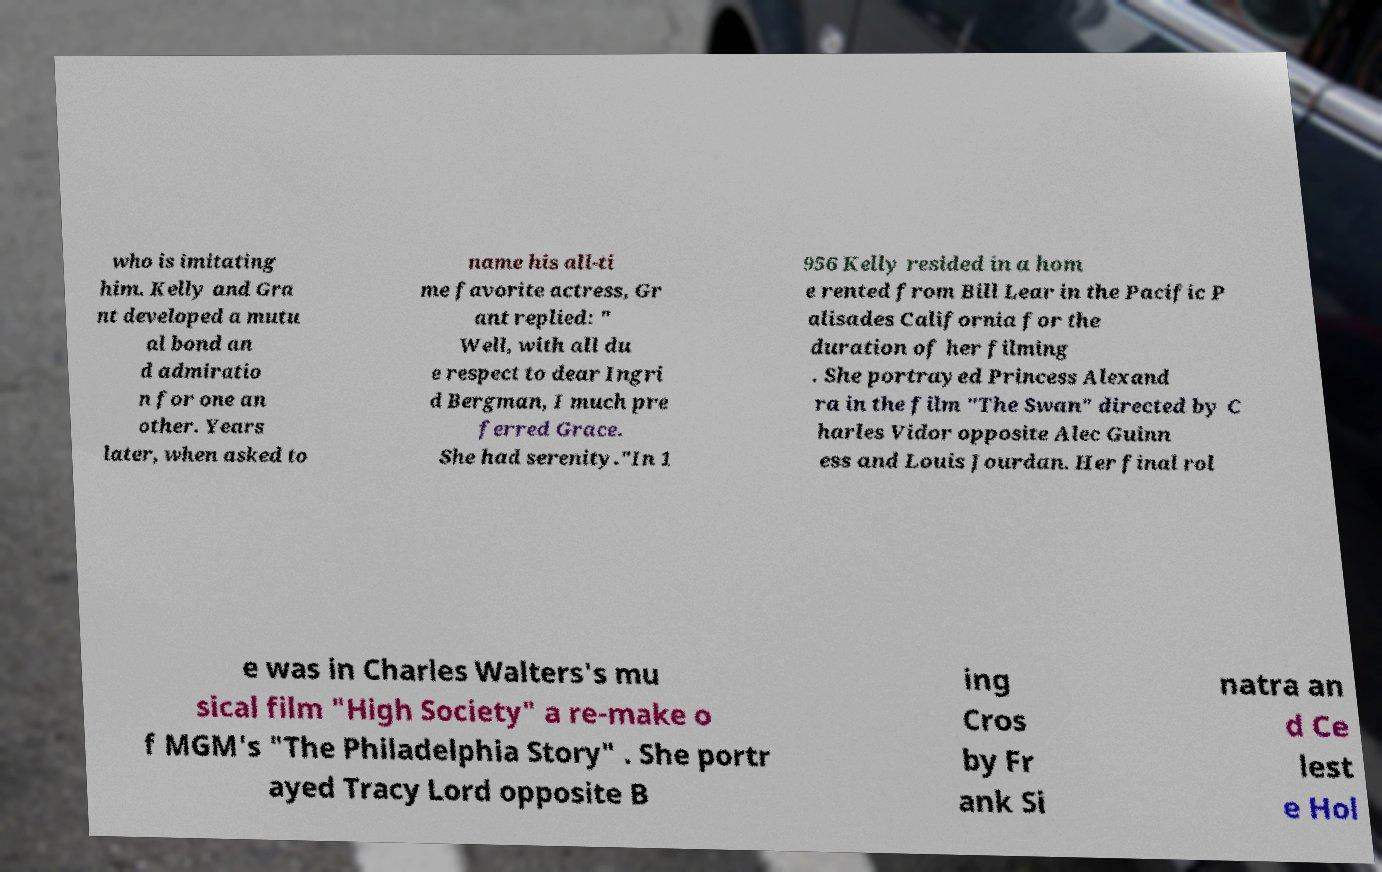I need the written content from this picture converted into text. Can you do that? who is imitating him. Kelly and Gra nt developed a mutu al bond an d admiratio n for one an other. Years later, when asked to name his all-ti me favorite actress, Gr ant replied: " Well, with all du e respect to dear Ingri d Bergman, I much pre ferred Grace. She had serenity."In 1 956 Kelly resided in a hom e rented from Bill Lear in the Pacific P alisades California for the duration of her filming . She portrayed Princess Alexand ra in the film "The Swan" directed by C harles Vidor opposite Alec Guinn ess and Louis Jourdan. Her final rol e was in Charles Walters's mu sical film "High Society" a re-make o f MGM's "The Philadelphia Story" . She portr ayed Tracy Lord opposite B ing Cros by Fr ank Si natra an d Ce lest e Hol 